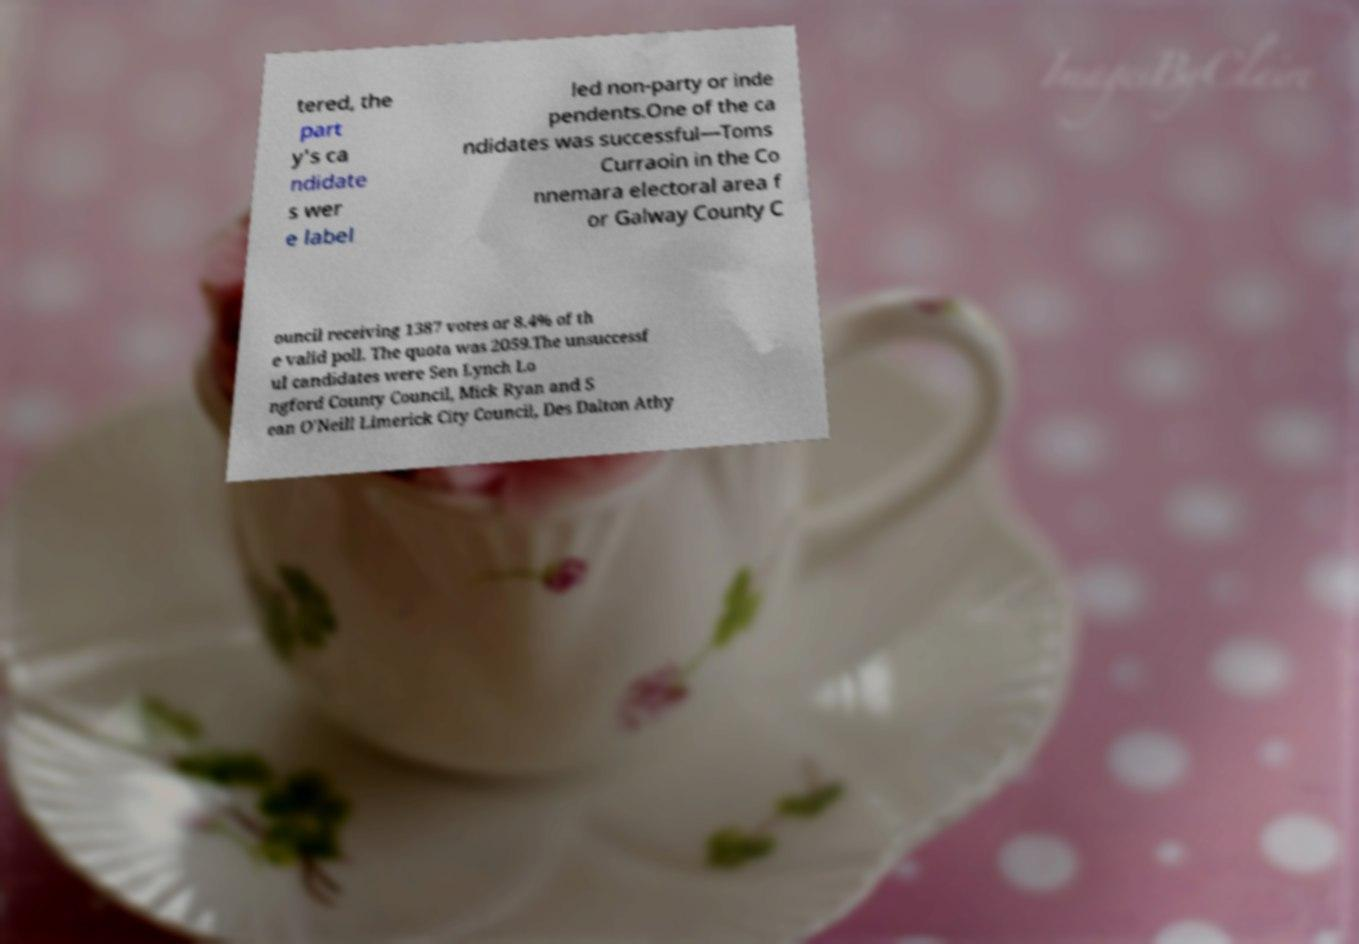Please identify and transcribe the text found in this image. tered, the part y's ca ndidate s wer e label led non-party or inde pendents.One of the ca ndidates was successful—Toms Curraoin in the Co nnemara electoral area f or Galway County C ouncil receiving 1387 votes or 8.4% of th e valid poll. The quota was 2059.The unsuccessf ul candidates were Sen Lynch Lo ngford County Council, Mick Ryan and S ean O'Neill Limerick City Council, Des Dalton Athy 